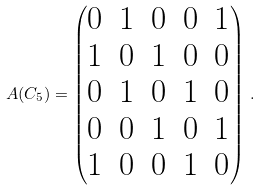Convert formula to latex. <formula><loc_0><loc_0><loc_500><loc_500>A ( C _ { 5 } ) = \begin{pmatrix} 0 & 1 & 0 & 0 & 1 \\ 1 & 0 & 1 & 0 & 0 \\ 0 & 1 & 0 & 1 & 0 \\ 0 & 0 & 1 & 0 & 1 \\ 1 & 0 & 0 & 1 & 0 \end{pmatrix} \, .</formula> 